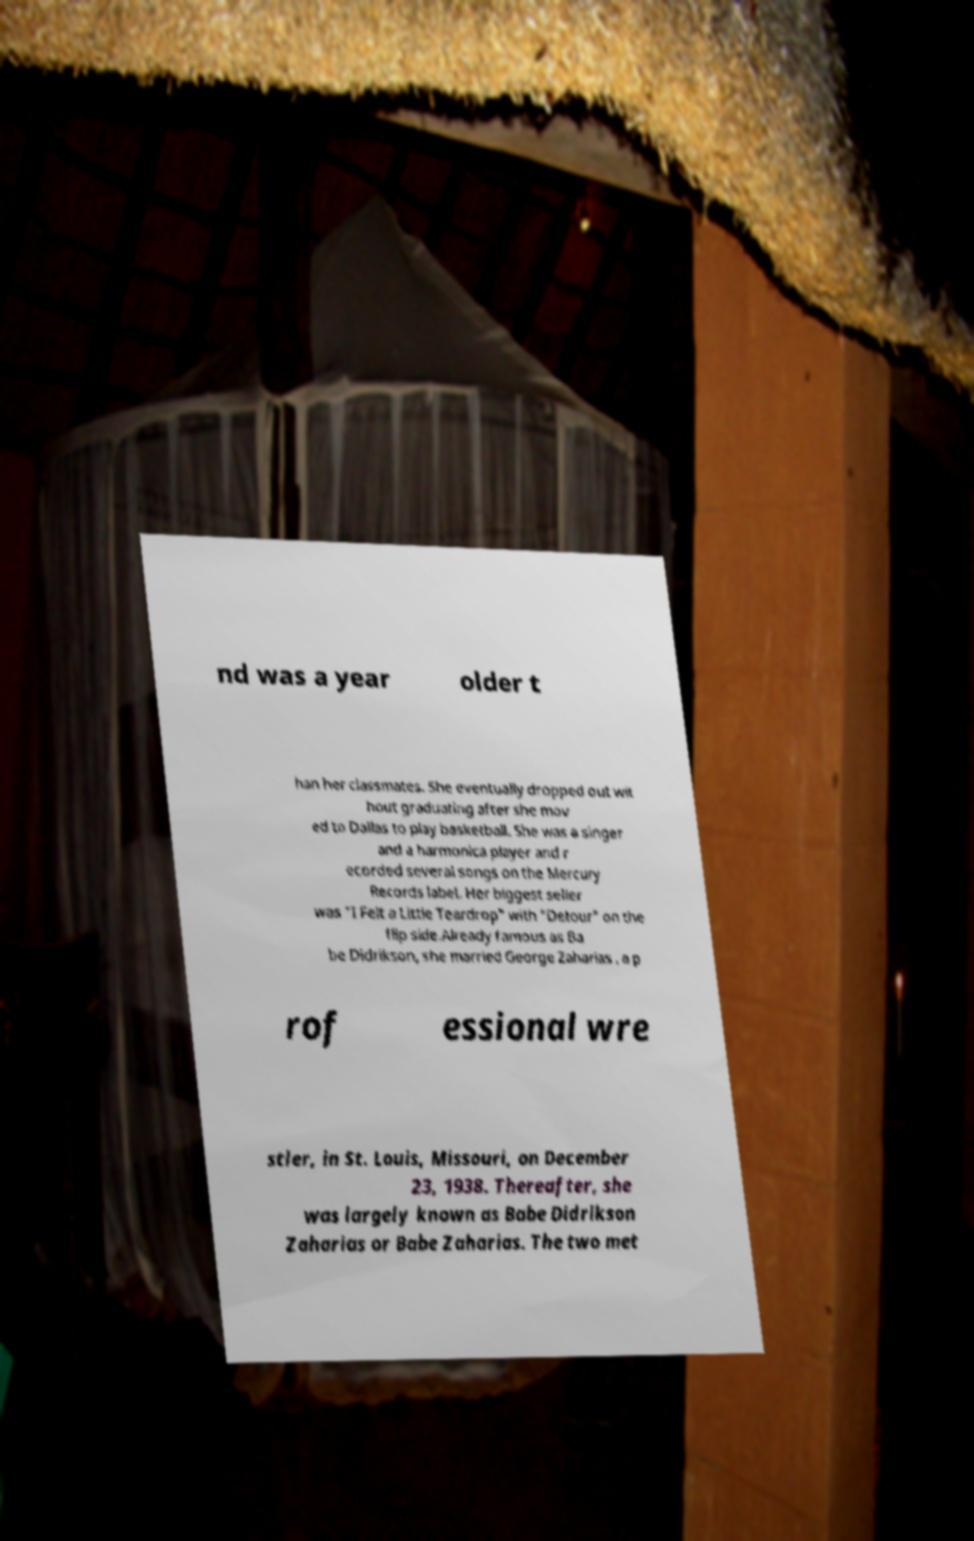Please read and relay the text visible in this image. What does it say? nd was a year older t han her classmates. She eventually dropped out wit hout graduating after she mov ed to Dallas to play basketball. She was a singer and a harmonica player and r ecorded several songs on the Mercury Records label. Her biggest seller was "I Felt a Little Teardrop" with "Detour" on the flip side.Already famous as Ba be Didrikson, she married George Zaharias , a p rof essional wre stler, in St. Louis, Missouri, on December 23, 1938. Thereafter, she was largely known as Babe Didrikson Zaharias or Babe Zaharias. The two met 